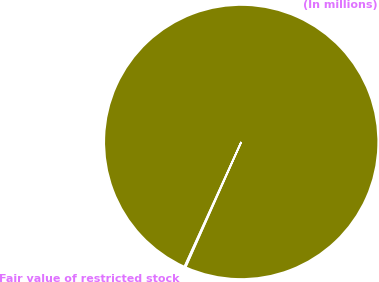<chart> <loc_0><loc_0><loc_500><loc_500><pie_chart><fcel>(In millions)<fcel>Fair value of restricted stock<nl><fcel>99.85%<fcel>0.15%<nl></chart> 